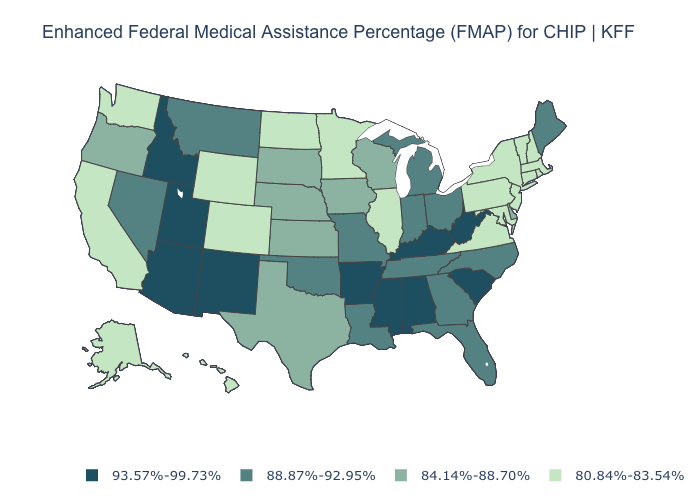Name the states that have a value in the range 93.57%-99.73%?
Write a very short answer. Alabama, Arizona, Arkansas, Idaho, Kentucky, Mississippi, New Mexico, South Carolina, Utah, West Virginia. Is the legend a continuous bar?
Concise answer only. No. Name the states that have a value in the range 93.57%-99.73%?
Be succinct. Alabama, Arizona, Arkansas, Idaho, Kentucky, Mississippi, New Mexico, South Carolina, Utah, West Virginia. Name the states that have a value in the range 88.87%-92.95%?
Be succinct. Florida, Georgia, Indiana, Louisiana, Maine, Michigan, Missouri, Montana, Nevada, North Carolina, Ohio, Oklahoma, Tennessee. Name the states that have a value in the range 80.84%-83.54%?
Be succinct. Alaska, California, Colorado, Connecticut, Hawaii, Illinois, Maryland, Massachusetts, Minnesota, New Hampshire, New Jersey, New York, North Dakota, Pennsylvania, Rhode Island, Vermont, Virginia, Washington, Wyoming. Name the states that have a value in the range 80.84%-83.54%?
Concise answer only. Alaska, California, Colorado, Connecticut, Hawaii, Illinois, Maryland, Massachusetts, Minnesota, New Hampshire, New Jersey, New York, North Dakota, Pennsylvania, Rhode Island, Vermont, Virginia, Washington, Wyoming. Does the map have missing data?
Give a very brief answer. No. Among the states that border Michigan , does Indiana have the highest value?
Write a very short answer. Yes. Name the states that have a value in the range 84.14%-88.70%?
Answer briefly. Delaware, Iowa, Kansas, Nebraska, Oregon, South Dakota, Texas, Wisconsin. What is the highest value in the USA?
Quick response, please. 93.57%-99.73%. Name the states that have a value in the range 93.57%-99.73%?
Write a very short answer. Alabama, Arizona, Arkansas, Idaho, Kentucky, Mississippi, New Mexico, South Carolina, Utah, West Virginia. Is the legend a continuous bar?
Be succinct. No. Does the map have missing data?
Answer briefly. No. How many symbols are there in the legend?
Short answer required. 4. Which states hav the highest value in the South?
Give a very brief answer. Alabama, Arkansas, Kentucky, Mississippi, South Carolina, West Virginia. 